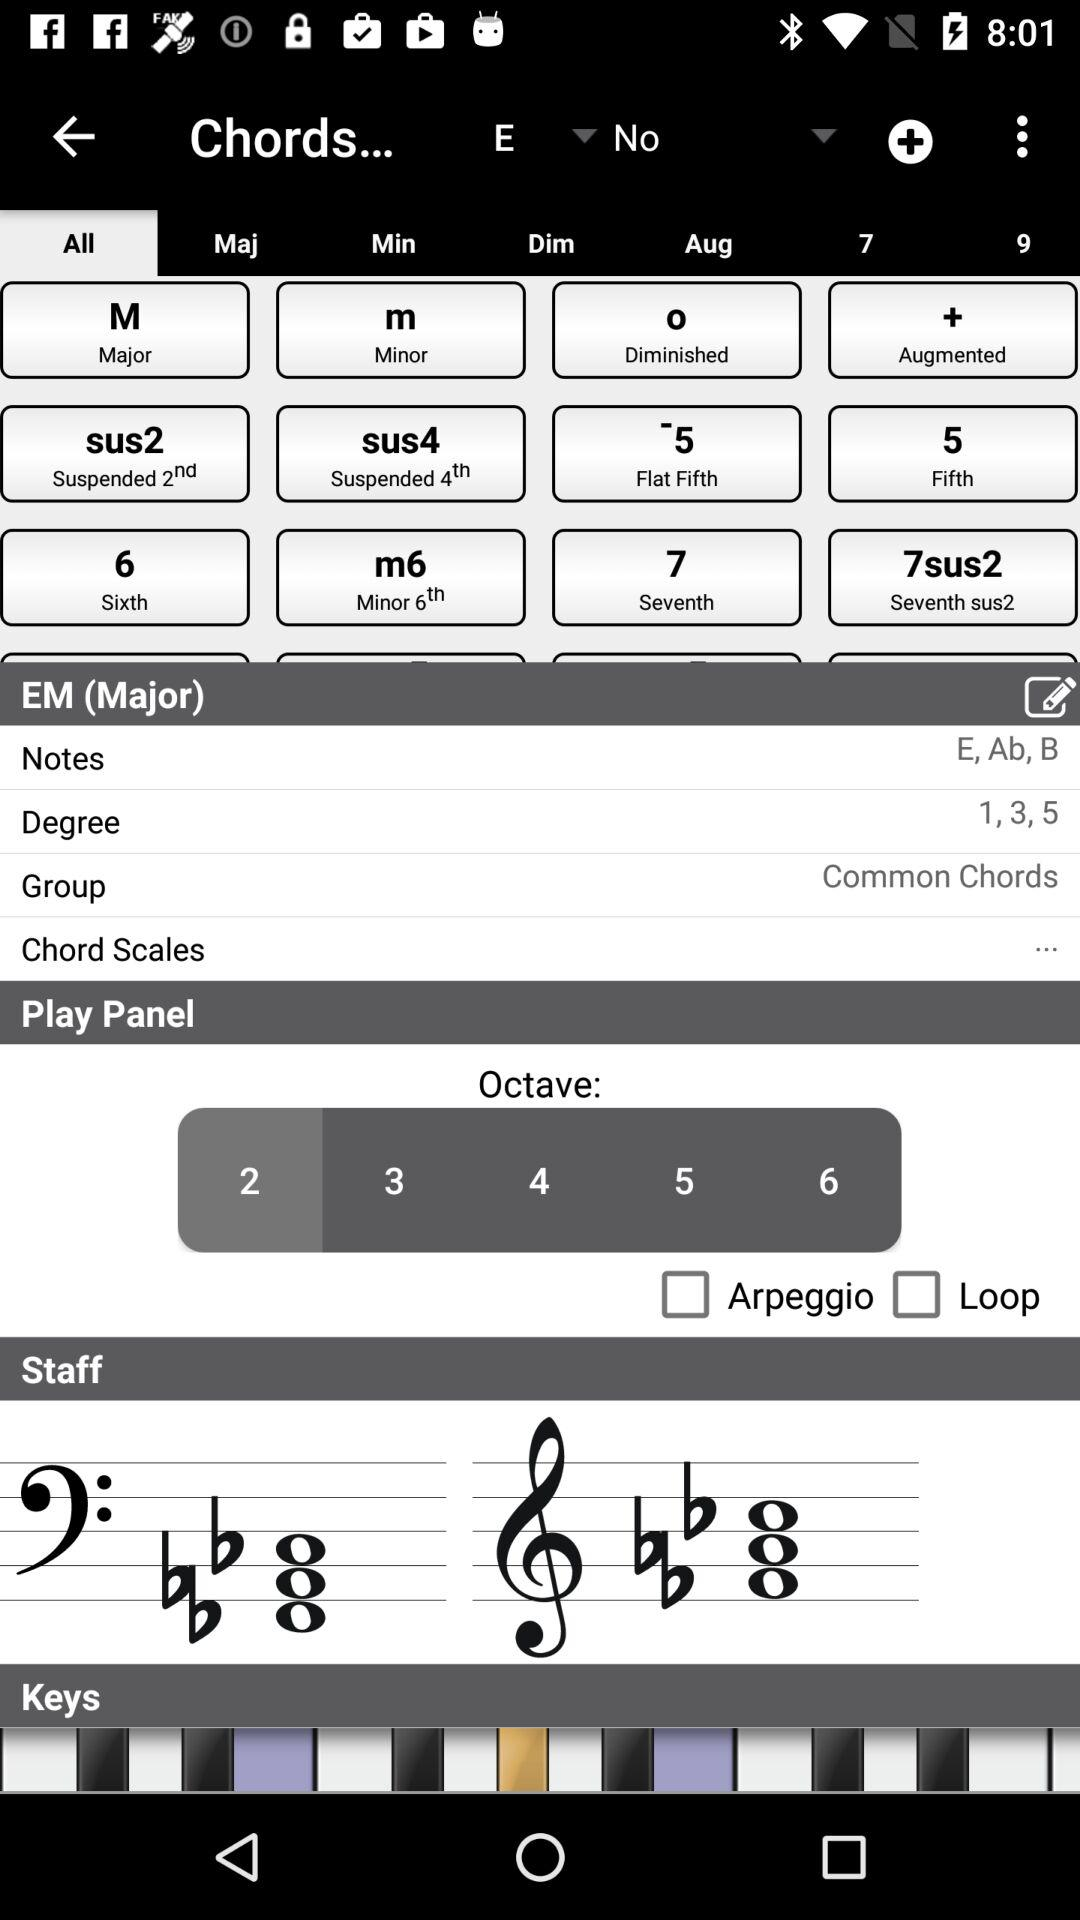What is the degree of "EM (Major)"? The degrees are 1, 3 and 5. 